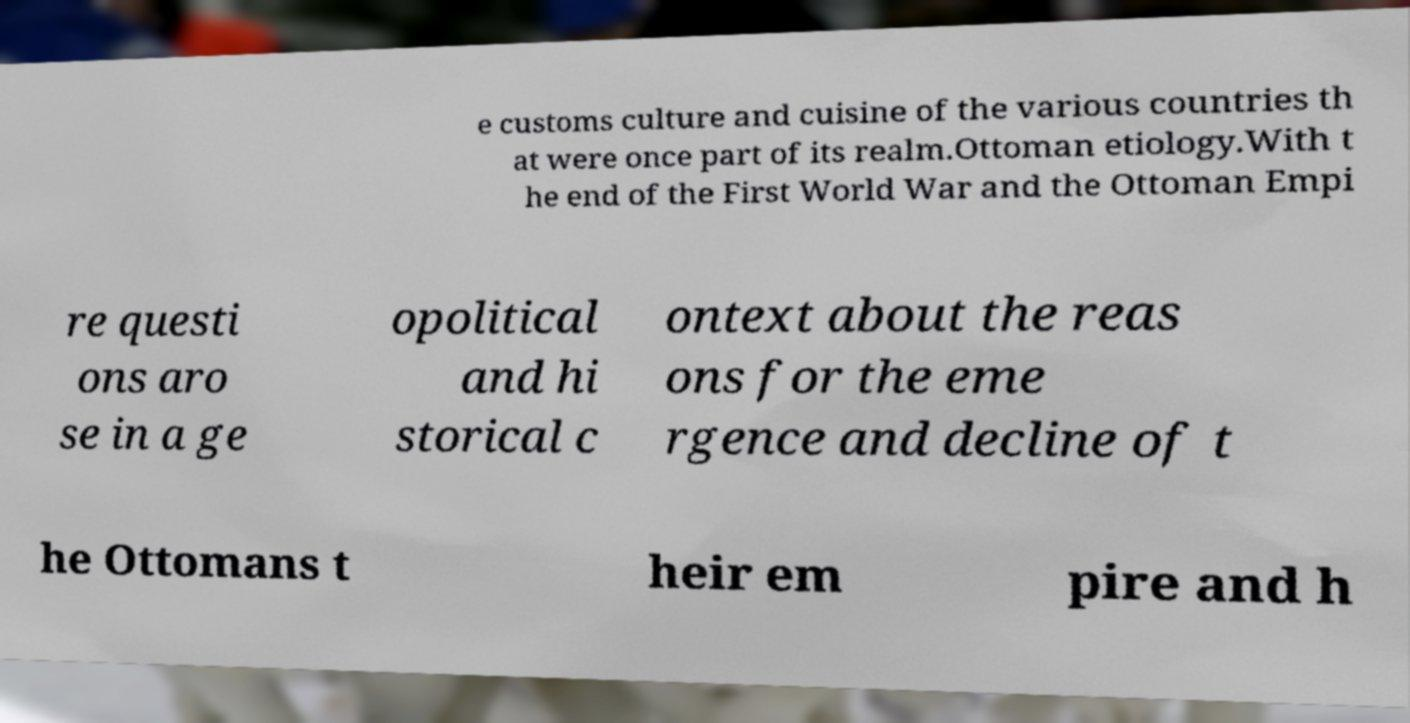For documentation purposes, I need the text within this image transcribed. Could you provide that? e customs culture and cuisine of the various countries th at were once part of its realm.Ottoman etiology.With t he end of the First World War and the Ottoman Empi re questi ons aro se in a ge opolitical and hi storical c ontext about the reas ons for the eme rgence and decline of t he Ottomans t heir em pire and h 